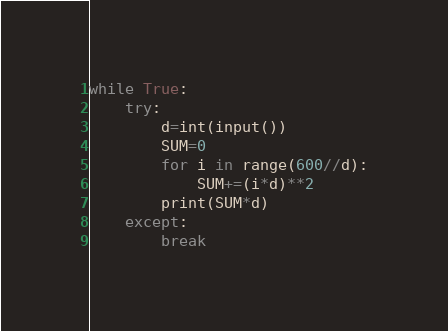Convert code to text. <code><loc_0><loc_0><loc_500><loc_500><_Python_>while True:
    try:
        d=int(input())
        SUM=0
        for i in range(600//d):
            SUM+=(i*d)**2
        print(SUM*d)
    except:
        break</code> 